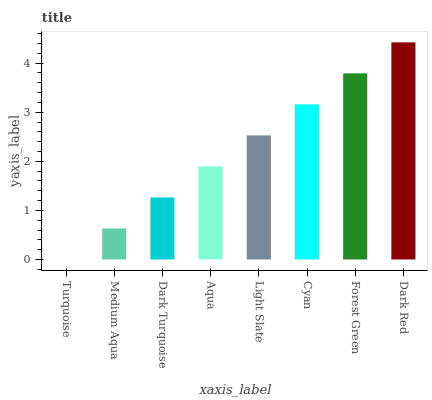Is Turquoise the minimum?
Answer yes or no. Yes. Is Dark Red the maximum?
Answer yes or no. Yes. Is Medium Aqua the minimum?
Answer yes or no. No. Is Medium Aqua the maximum?
Answer yes or no. No. Is Medium Aqua greater than Turquoise?
Answer yes or no. Yes. Is Turquoise less than Medium Aqua?
Answer yes or no. Yes. Is Turquoise greater than Medium Aqua?
Answer yes or no. No. Is Medium Aqua less than Turquoise?
Answer yes or no. No. Is Light Slate the high median?
Answer yes or no. Yes. Is Aqua the low median?
Answer yes or no. Yes. Is Dark Turquoise the high median?
Answer yes or no. No. Is Turquoise the low median?
Answer yes or no. No. 